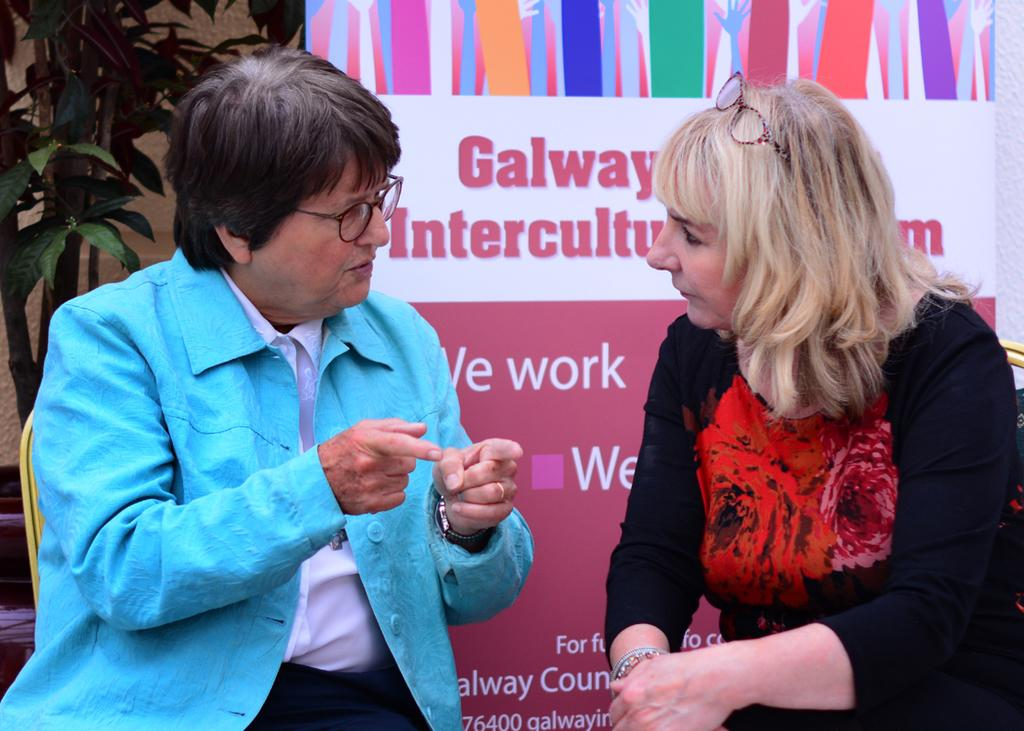How many people are sitting in the image? There are two persons sitting on chairs in the image. What is behind the persons? There is a wall behind the persons. What can be seen on the wall? There is a big banner with some text on the wall. What type of vegetation is present in the image? There is a plant in the image. What objects are visible on the surface? There are objects on the surface, but their specific nature is not mentioned in the facts. What type of education is the friend in the image pursuing? There is no mention of a friend or education in the image, so this question cannot be answered. How many bananas are visible in the image? There is no mention of bananas in the image, so this question cannot be answered. 